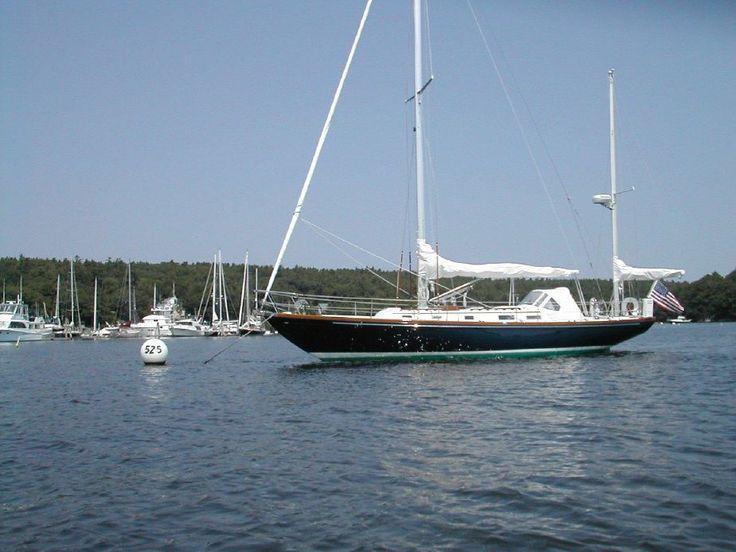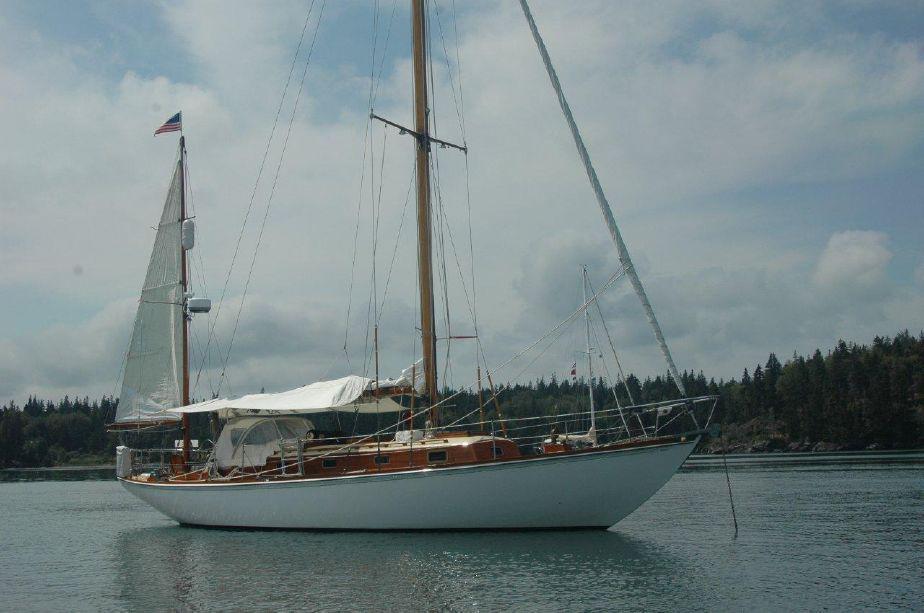The first image is the image on the left, the second image is the image on the right. For the images displayed, is the sentence "An image shows a dark-bodied boat with its main sail still furled." factually correct? Answer yes or no. Yes. 